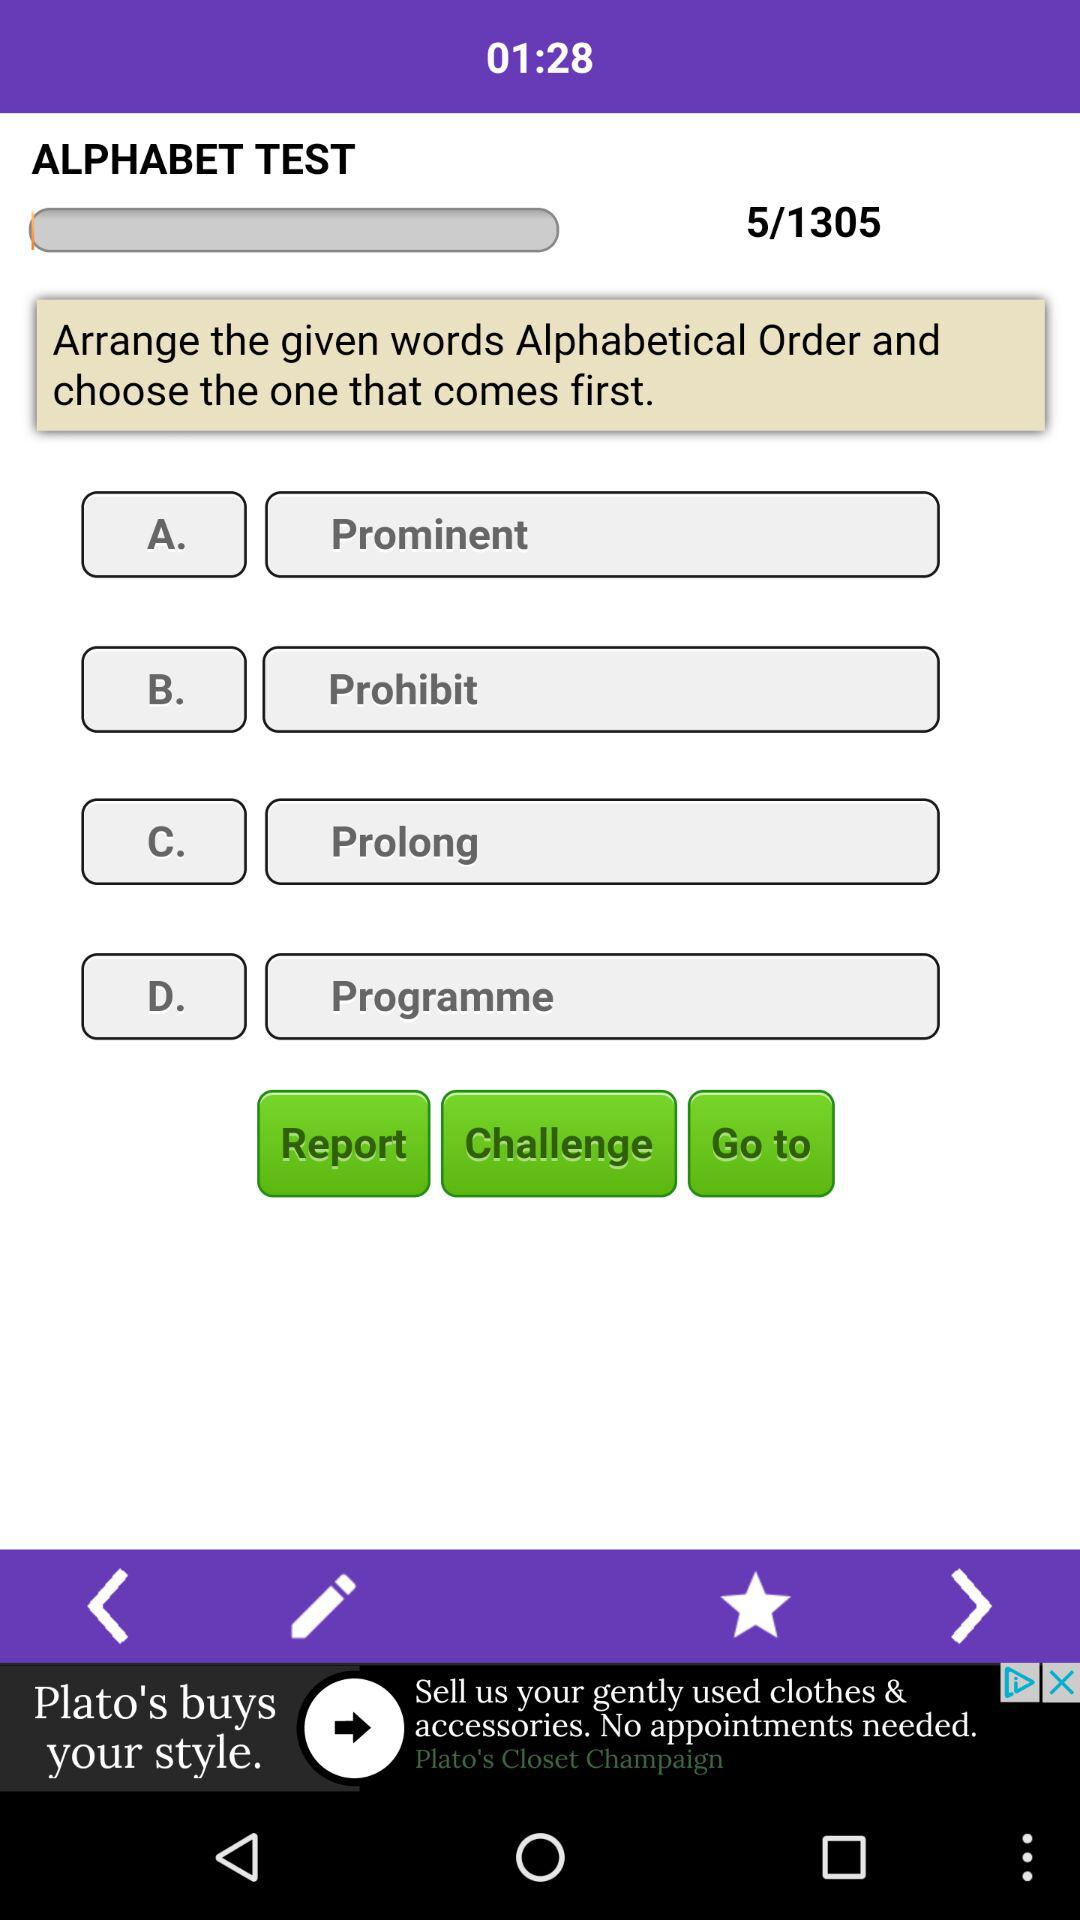What question am I asking? You are asking question number 5. 